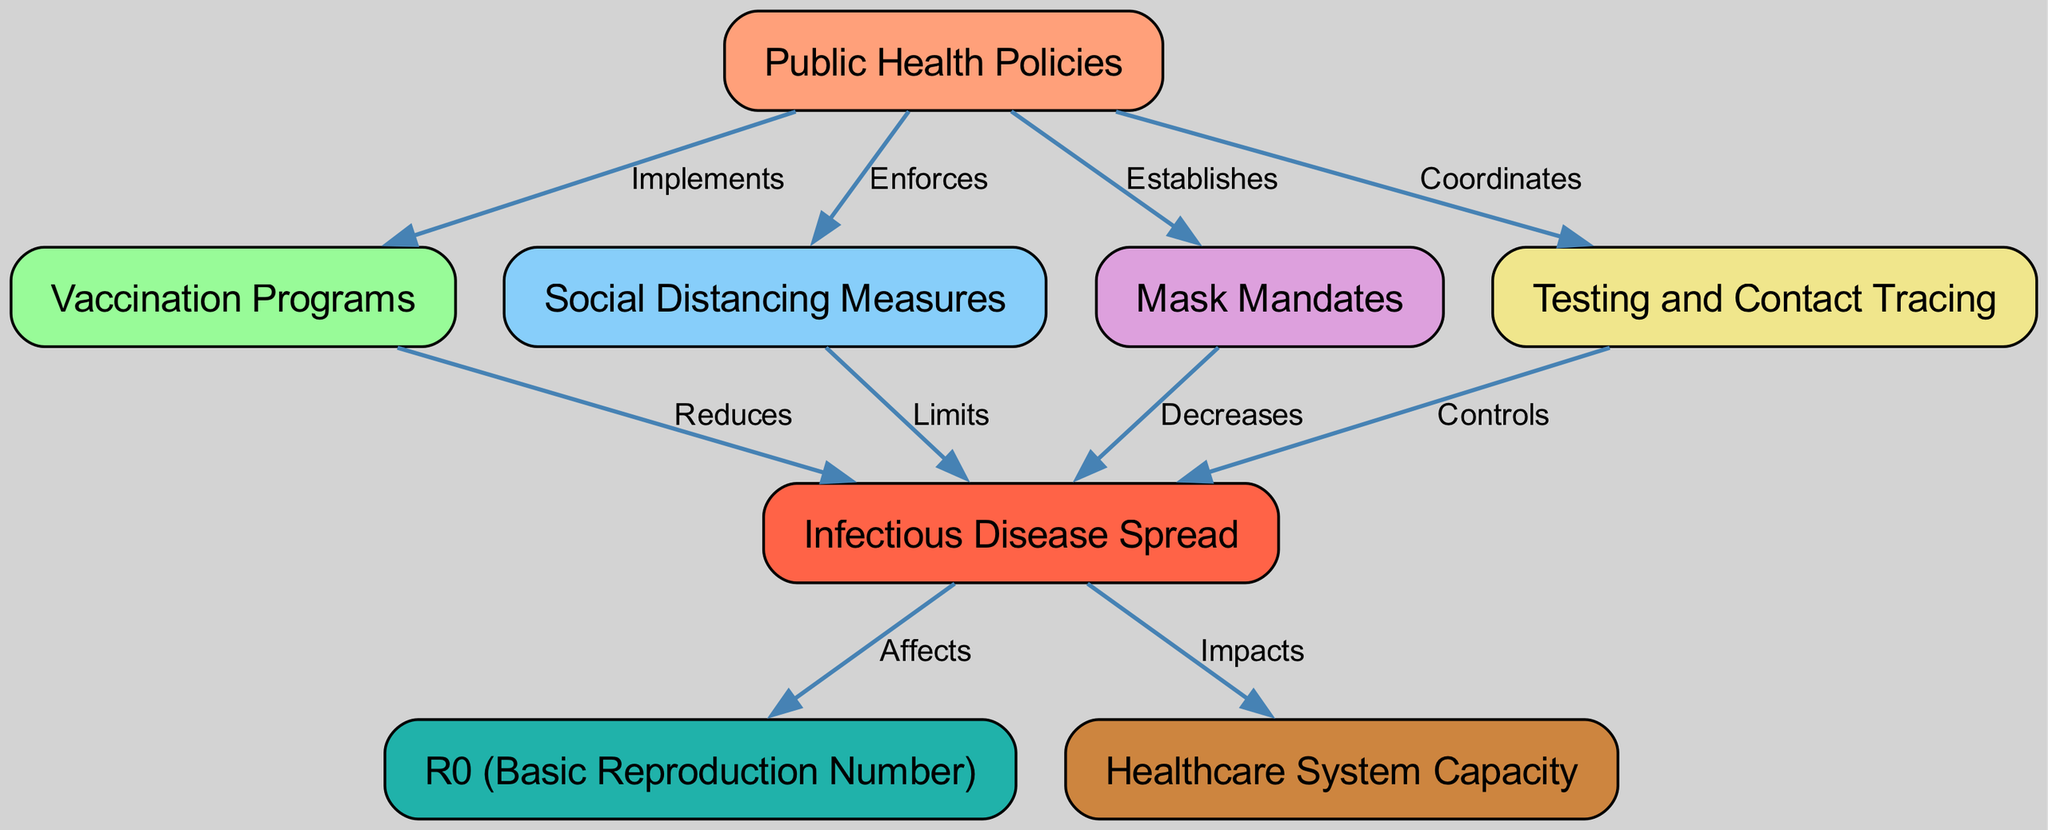What is the total number of nodes in the diagram? The diagram contains eight distinct nodes: Public Health Policies, Vaccination Programs, Social Distancing Measures, Mask Mandates, Testing and Contact Tracing, Infectious Disease Spread, R0, and Healthcare System Capacity. Counting these gives a total of 8 nodes.
Answer: 8 What is the relationship between public health policies and vaccination programs? The edge connecting these two nodes is labeled "Implements," indicating that public health policies implement vaccination programs as part of their strategy.
Answer: Implements Which policy specifically limits the spread of disease? The node for Social Distancing Measures is directly connected to the Infectious Disease Spread node with the label "Limits," denoting that social distancing specifically limits disease spread.
Answer: Social Distancing Measures How does the spread of infectious diseases affect R0? The edge from Infectious Disease Spread to R0 is labeled "Affects," indicating that the spread of diseases influences the basic reproduction number (R0).
Answer: Affects What is the impact of testing and contact tracing on disease spread? The edge connecting Testing and Contact Tracing to Infectious Disease Spread is labeled "Controls," which indicates that efficient testing and contact tracing help control the spread of diseases.
Answer: Controls Which node is affected by the spread of infectious diseases in terms of healthcare capacity? The relationship between Infectious Disease Spread and Healthcare System Capacity is indicated by the edge labeled "Impacts," showing that the disease spread impacts healthcare capacity.
Answer: Impacts What two public health policies decrease the spread of infectious diseases? The edges labeled "Decreases" for Mask Mandates and "Limits" for Social Distancing both indicate these policies decrease the spread of infectious diseases.
Answer: Mask Mandates, Social Distancing Measures Which node illustrates the basic reproduction number? The node representing the basic reproduction number is labeled R0, indicating its importance in understanding disease transmission dynamics.
Answer: R0 What action does public health policy take related to mask mandates? The edge leading to the Mask Mandates node is labeled "Establishes," signifying that public health policies establish mask mandates as a health intervention.
Answer: Establishes 